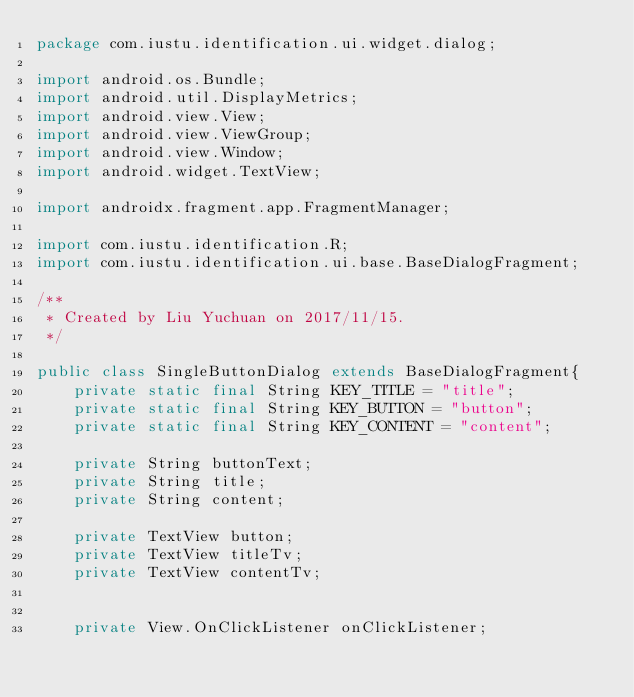Convert code to text. <code><loc_0><loc_0><loc_500><loc_500><_Java_>package com.iustu.identification.ui.widget.dialog;

import android.os.Bundle;
import android.util.DisplayMetrics;
import android.view.View;
import android.view.ViewGroup;
import android.view.Window;
import android.widget.TextView;

import androidx.fragment.app.FragmentManager;

import com.iustu.identification.R;
import com.iustu.identification.ui.base.BaseDialogFragment;

/**
 * Created by Liu Yuchuan on 2017/11/15.
 */

public class SingleButtonDialog extends BaseDialogFragment{
    private static final String KEY_TITLE = "title";
    private static final String KEY_BUTTON = "button";
    private static final String KEY_CONTENT = "content";

    private String buttonText;
    private String title;
    private String content;

    private TextView button;
    private TextView titleTv;
    private TextView contentTv;


    private View.OnClickListener onClickListener;
</code> 